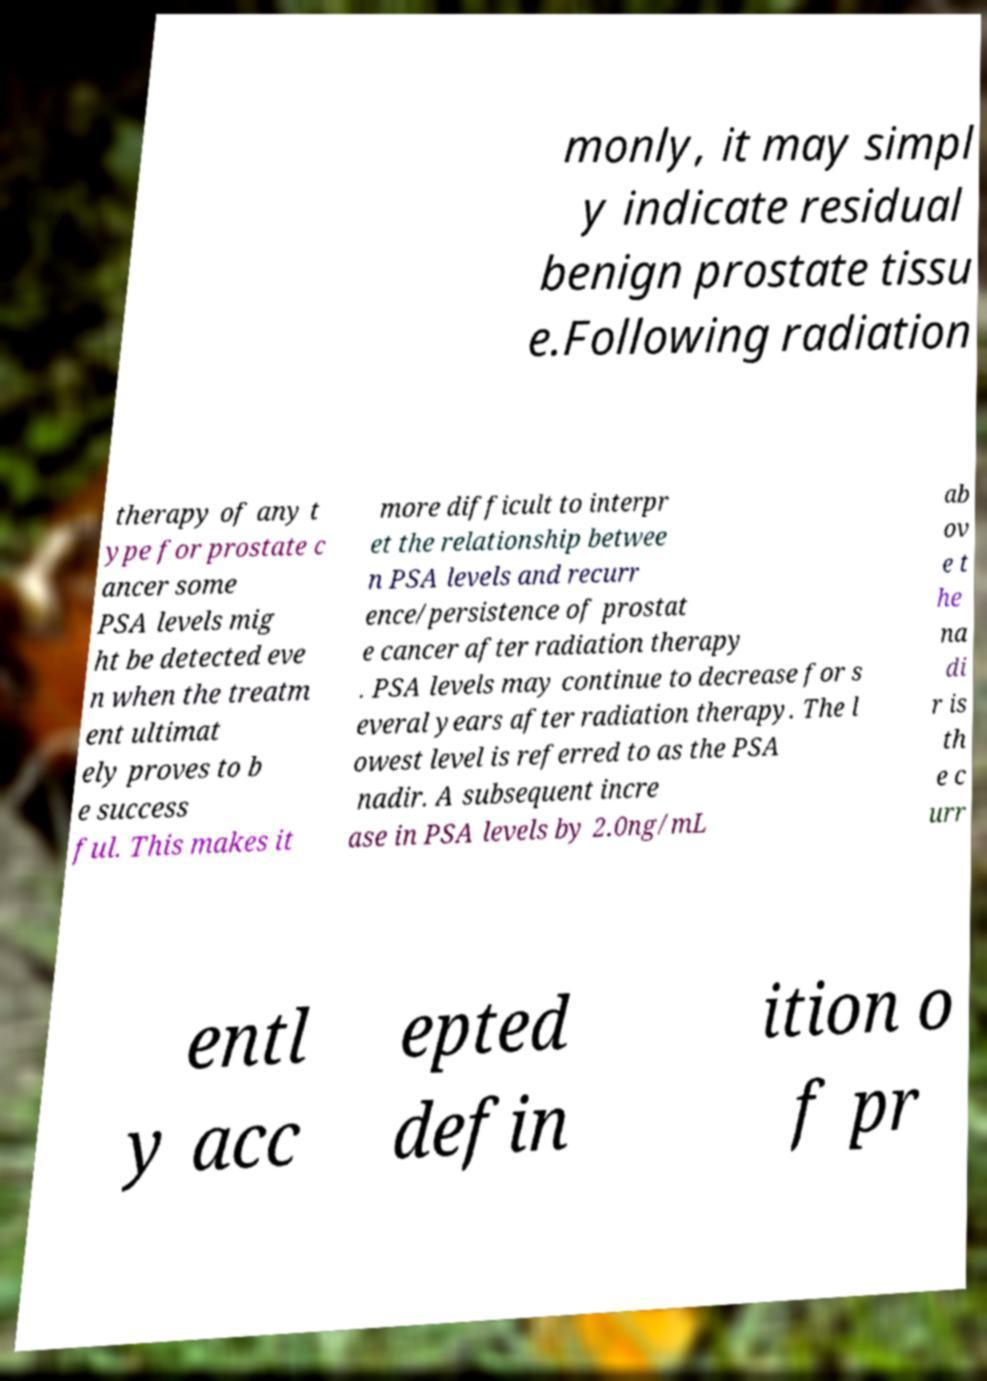I need the written content from this picture converted into text. Can you do that? monly, it may simpl y indicate residual benign prostate tissu e.Following radiation therapy of any t ype for prostate c ancer some PSA levels mig ht be detected eve n when the treatm ent ultimat ely proves to b e success ful. This makes it more difficult to interpr et the relationship betwee n PSA levels and recurr ence/persistence of prostat e cancer after radiation therapy . PSA levels may continue to decrease for s everal years after radiation therapy. The l owest level is referred to as the PSA nadir. A subsequent incre ase in PSA levels by 2.0ng/mL ab ov e t he na di r is th e c urr entl y acc epted defin ition o f pr 